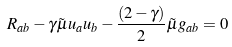<formula> <loc_0><loc_0><loc_500><loc_500>R _ { a b } - \gamma \tilde { \mu } u _ { a } u _ { b } - \frac { ( 2 - \gamma ) } 2 \tilde { \mu } g _ { a b } = 0</formula> 